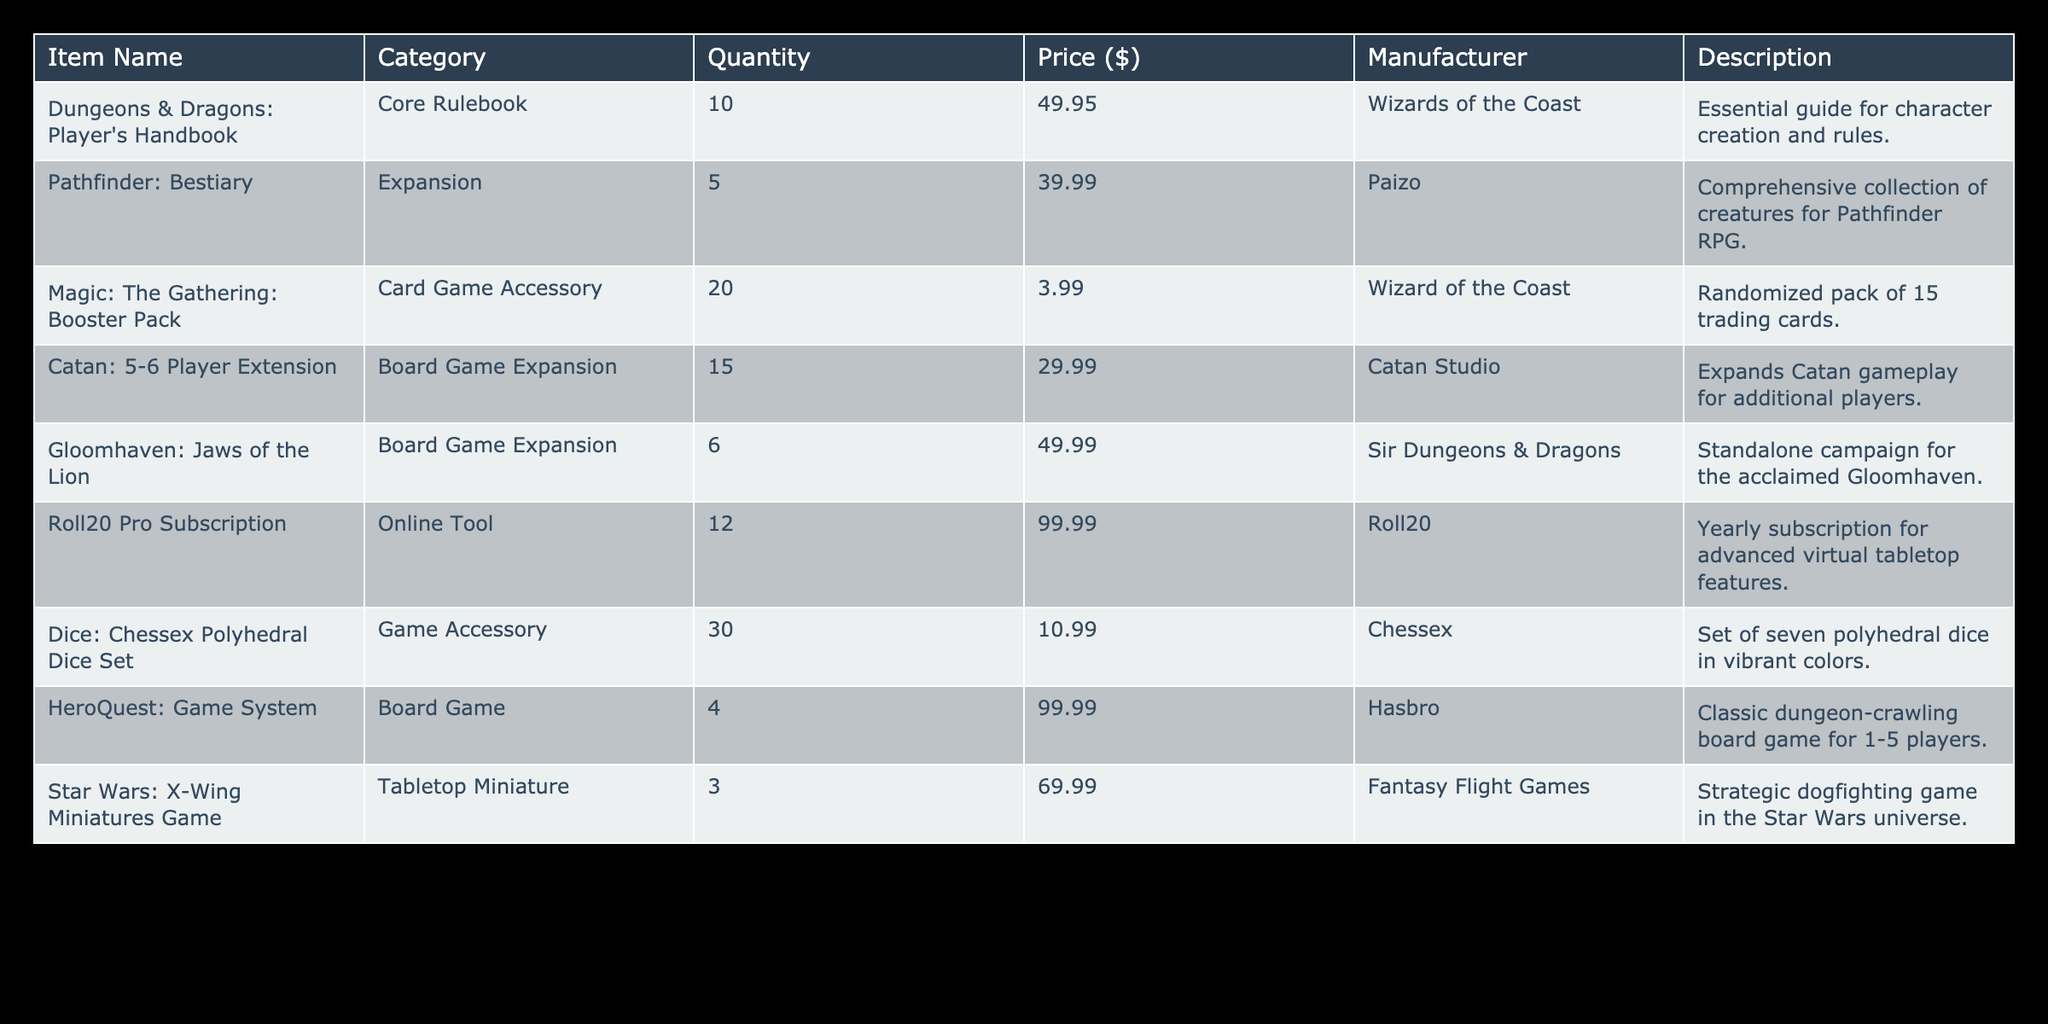What is the total quantity of card game accessories available? The only card game accessory listed is "Magic: The Gathering: Booster Pack," which has a quantity of 20. Hence, the total quantity of card game accessories is just 20.
Answer: 20 Which item has the highest price? By scanning the price column, "HeroQuest: Game System" and "Roll20 Pro Subscription" both have a price of 99.99, which is the highest price among all items.
Answer: HeroQuest: Game System and Roll20 Pro Subscription How much would it cost to buy all the Dungeons & Dragons: Player's Handbook available? There are 10 copies available, each priced at 49.95. Therefore, the total cost would be 10 * 49.95 = 499.50.
Answer: 499.50 Is there any board game listed in the inventory? Yes, by reviewing the table, both "Catan: 5-6 Player Extension" and "HeroQuest: Game System" are classified under the board game category.
Answer: Yes What is the average price of game accessories in the inventory? The game accessories are "Magic: The Gathering: Booster Pack," "Dice: Chessex Polyhedral Dice Set," and "Roll20 Pro Subscription." Their prices are 3.99, 10.99, and 99.99 respectively. The average price is calculated as (3.99 + 10.99 + 99.99) / 3 = 38.99.
Answer: 38.99 How many expansions are available for Pathfinder and Gloomhaven combined? There is 1 expansion for Pathfinder, which is "Pathfinder: Bestiary," and 1 expansion for Gloomhaven titled "Gloomhaven: Jaws of the Lion." Therefore, combining them, the total is 1 + 1 = 2 expansions.
Answer: 2 Are there more than 15 items in the inventory? By adding up all the quantity numbers in the inventory (10 + 5 + 20 + 15 + 6 + 12 + 30 + 4 + 3), we find that the total is 105. Hence, there is clearly more than 15 items.
Answer: Yes What is the total cost of all the expansions in the inventory? The expansions in the inventory are "Pathfinder: Bestiary" ($39.99), "Catan: 5-6 Player Extension" ($29.99), and "Gloomhaven: Jaws of the Lion" ($49.99). The total cost is calculated as 39.99 + 29.99 + 49.99 = 119.97.
Answer: 119.97 Which manufacturer produces the most items in the inventory? By reviewing the manufacturers' column, Wizards of the Coast appears 2 times ("Dungeons & Dragons: Player's Handbook" and "Magic: The Gathering: Booster Pack"), which is more than any other manufacturer.
Answer: Wizards of the Coast 